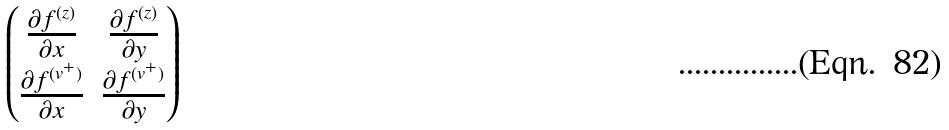Convert formula to latex. <formula><loc_0><loc_0><loc_500><loc_500>\begin{pmatrix} \frac { \partial f ^ { ( z ) } } { \partial x } & \frac { \partial f ^ { ( z ) } } { \partial y } \\ \frac { \partial f ^ { ( v ^ { + } ) } } { \partial x } & \frac { \partial f ^ { ( v ^ { + } ) } } { \partial y } \end{pmatrix}</formula> 